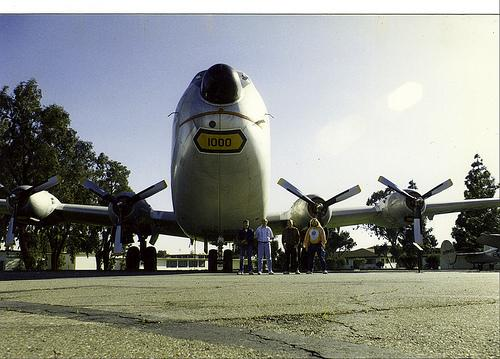What unique characteristic can be observed on the airplane's nose?  The airplane's nose is black, and it also has a black nose cone. How many engines does the large plane have, and where are its propellers? The large plane has four engines, and the propellers are in front of two of the engines on the airplane's wing. What are the men close to the plane wearing? There are men wearing a yellow and white shirt, a plaid shirt, a white shirt, and a black jacket. How would you describe the sky in the image? The sky in the image is hazy. Count the number of wheels on the large silver airplane. The large silver airplane has six wheels. Analyze the object interactions in the image and provide a brief description. The men are standing in front of the parked airplane, interacting with each other and possibly observing the plane, while various objects like trees and buildings surround the scene. Comment on the quality and sentiment of the image. The image has an interesting composition, evoking a sense of curiosity and fascination with the airplane and its surroundings. What kind of trees are around the airplane, and are there any buildings nearby? There are trees with green leaves near the plane, and a house and some buildings in the background behind the airplane. Identify the main aircraft's color and the activity it is engaged in. The main aircraft is silver and it is parked on the runway. Give a brief description of the ground where the airplane is parked. The airplane is parked on a cracked concrete runway with lots of cracks on the ground. Identify the sentiment associated with the cracked concrete runway. Negative sentiment Identify the attributes of the airplane. Silver color, four engines, metal propeller, black nose, black tires, and landing gear with six wheels. Analyze the color of the airplane's cabin. The airplane's cabin is black. Describe the scene with the airplane. A large silver plane with four engines is parked on a cracked concrete runway near trees and buildings. There are men standing in front of it, one of them wearing a yellow and white shirt.  Explain the position of trees in relation to the airplane. The trees are behind and near the airplane, mostly on the left side. Analyze the interaction between the men and the plane. The men are standing near the plane, possibly inspecting or discussing it. Investigate the interaction between the men standing near the plane. The men appear to be discussing or inspecting the airplane. Determine the quality of the image in terms of clarity and focus. Good clarity and focus, but a hazy sky affects overall quality. Detect any faults in the image or any objects that might seem out of place. No objects are out of place, but the cracked runway and hazy sky are noticeable faults. Determine the sentiment of the image. Neutral Read the text on the black and yellow plaque. 1000 Which object is nearest to the silver plane: the trees or the house? The trees. How many engines does the airplane have? The airplane has four engines. Evaluate the quality of the image. Good overall quality with some haziness in the sky area. Identify any anomalies or unusual elements in the image. The cracked concrete runway and the haziness in the sky are unusual elements. Determine what the man dressed in a yellow and white shirt is doing in the image. Standing in front of the plane with other men, possibly inspecting or discussing the airplane. Describe the runway where the airplane is parked. The runway is made of cracked concrete and has lots of cracks on the ground. List the objects and people present in the image. Silver plane, men (one in yellow and white shirt, one in plaid shirt, one in white shirt, one in black jacket), cracked concrete runway, trees, yellow and black plaque, metal propeller, black nose on plane, black tires, house, and a sign reading 1000. Match the description "man wearing a yellow sweatshirt" to the object in the image. Yellow and white shirt object: X:305 Y:225 Width:21 Height:21 